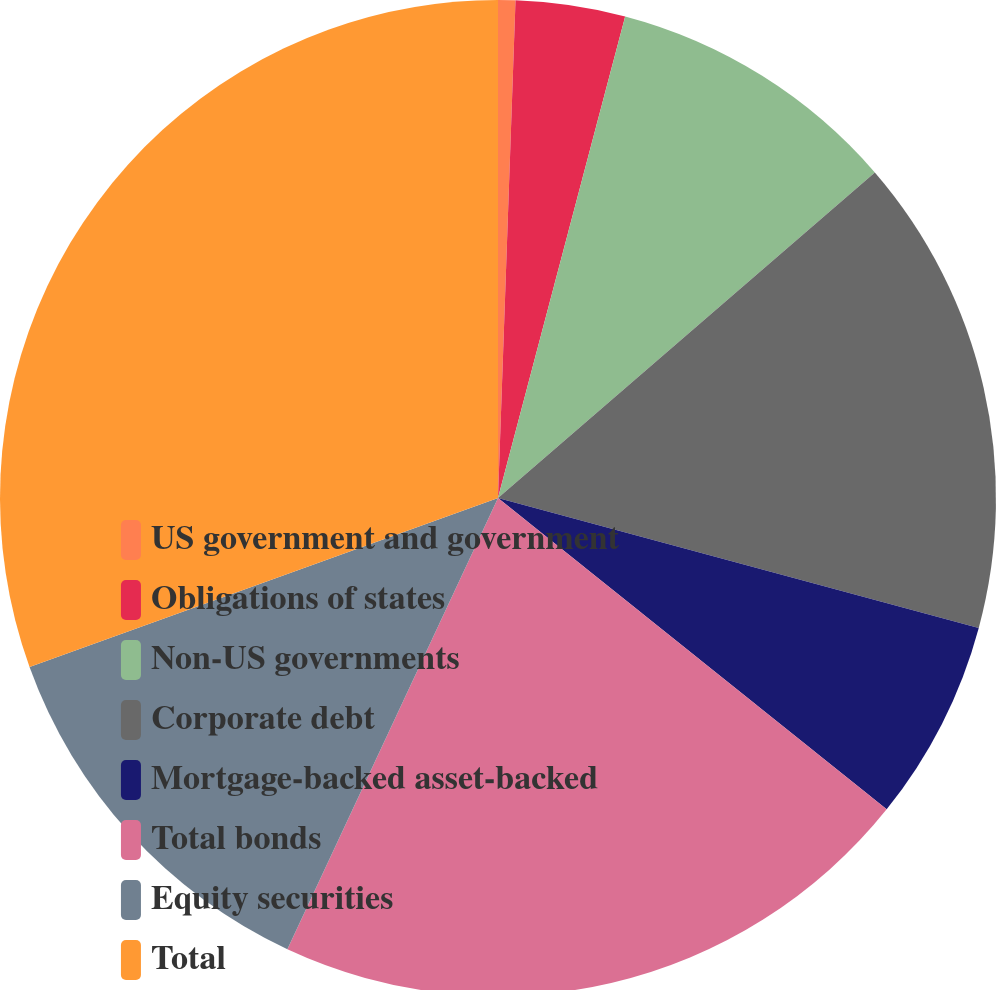Convert chart to OTSL. <chart><loc_0><loc_0><loc_500><loc_500><pie_chart><fcel>US government and government<fcel>Obligations of states<fcel>Non-US governments<fcel>Corporate debt<fcel>Mortgage-backed asset-backed<fcel>Total bonds<fcel>Equity securities<fcel>Total<nl><fcel>0.56%<fcel>3.55%<fcel>9.55%<fcel>15.54%<fcel>6.55%<fcel>21.2%<fcel>12.54%<fcel>30.51%<nl></chart> 